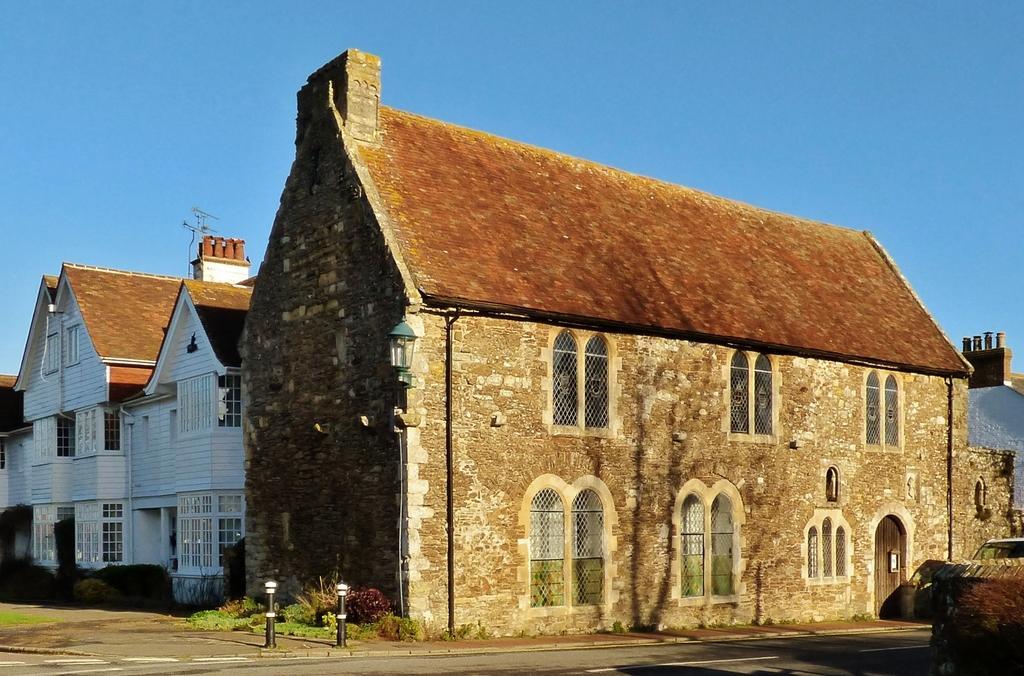Can you describe this image briefly? In this image, we can see buildings. There are poles at the bottom of the image. In the background of the image, there is a sky. 